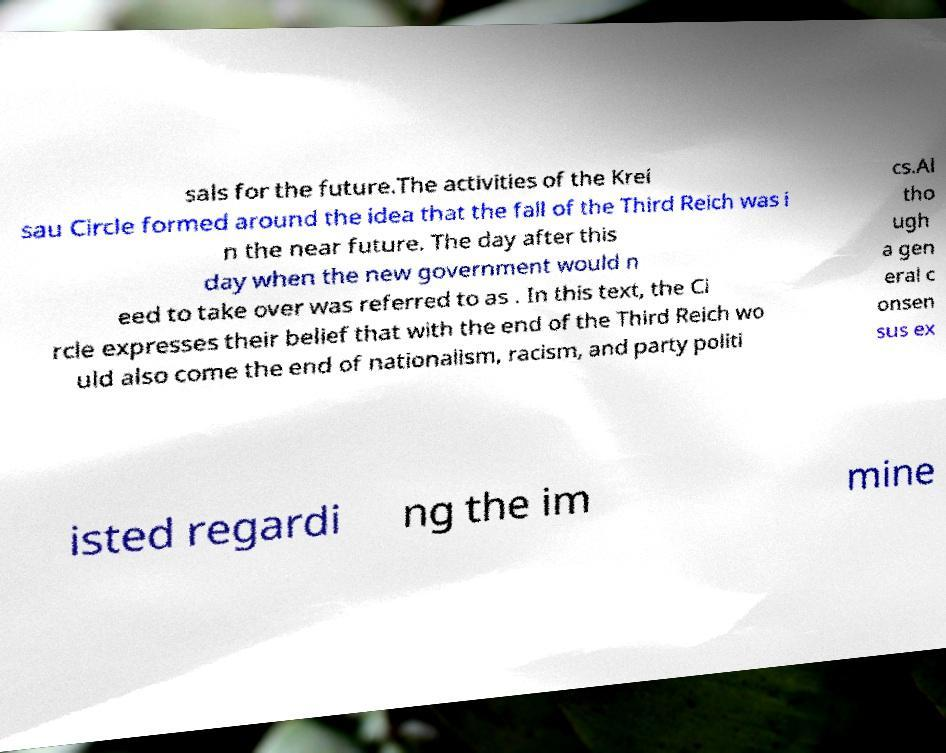Can you read and provide the text displayed in the image?This photo seems to have some interesting text. Can you extract and type it out for me? sals for the future.The activities of the Krei sau Circle formed around the idea that the fall of the Third Reich was i n the near future. The day after this day when the new government would n eed to take over was referred to as . In this text, the Ci rcle expresses their belief that with the end of the Third Reich wo uld also come the end of nationalism, racism, and party politi cs.Al tho ugh a gen eral c onsen sus ex isted regardi ng the im mine 